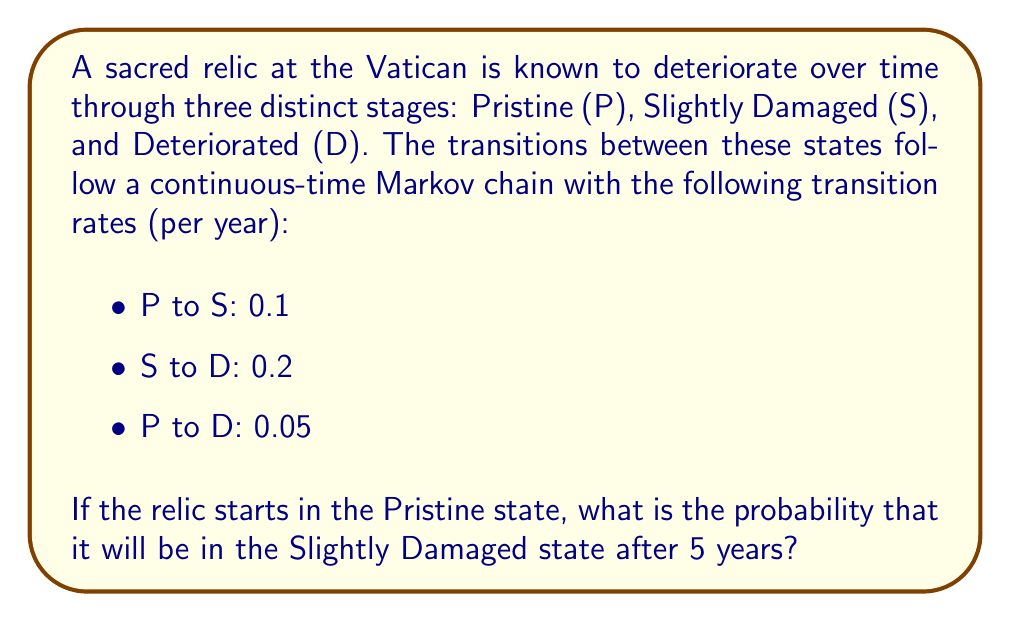What is the answer to this math problem? To solve this problem, we need to use the continuous-time Markov chain model and calculate the transition probabilities over time. Let's approach this step-by-step:

1) First, we need to set up the infinitesimal generator matrix Q:

   $$Q = \begin{bmatrix}
   -0.15 & 0.1 & 0.05 \\
   0 & -0.2 & 0.2 \\
   0 & 0 & 0
   \end{bmatrix}$$

2) The transition probability matrix after time t is given by:

   $$P(t) = e^{Qt}$$

3) To calculate this matrix exponential, we can use the spectral decomposition method:

   $$P(t) = Ve^{Dt}V^{-1}$$

   where D is a diagonal matrix of eigenvalues and V is a matrix of eigenvectors.

4) The eigenvalues of Q are:

   $$\lambda_1 = 0, \lambda_2 = -0.15, \lambda_3 = -0.2$$

5) The corresponding eigenvectors form the matrix V:

   $$V = \begin{bmatrix}
   1 & 1 & 1 \\
   1 & -\frac{2}{3} & 4 \\
   1 & \frac{1}{3} & -4
   \end{bmatrix}$$

6) The inverse of V is:

   $$V^{-1} = \frac{1}{15}\begin{bmatrix}
   9 & 1 & 1 \\
   -6 & 3 & 3 \\
   2 & -1 & 1
   \end{bmatrix}$$

7) Now we can calculate P(t):

   $$P(t) = \frac{1}{15}\begin{bmatrix}
   9+6e^{-0.15t}+0.2e^{-0.2t} & 1-4e^{-0.15t}+3e^{-0.2t} & 1-2e^{-0.15t}-3e^{-0.2t} \\
   6-6e^{-0.15t}+0.8e^{-0.2t} & 1+4e^{-0.15t}-5e^{-0.2t} & 4-4e^{-0.15t}+4e^{-0.2t} \\
   0 & 0 & 15
   \end{bmatrix}$$

8) The probability of being in the Slightly Damaged state after starting in the Pristine state is given by the element P_{12}(t). For t = 5:

   $$P_{12}(5) = \frac{1}{15}(1-4e^{-0.15 \cdot 5}+3e^{-0.2 \cdot 5})$$

9) Calculating this:

   $$P_{12}(5) \approx 0.3935$$

Therefore, the probability that the relic will be in the Slightly Damaged state after 5 years is approximately 0.3935 or 39.35%.
Answer: 0.3935 